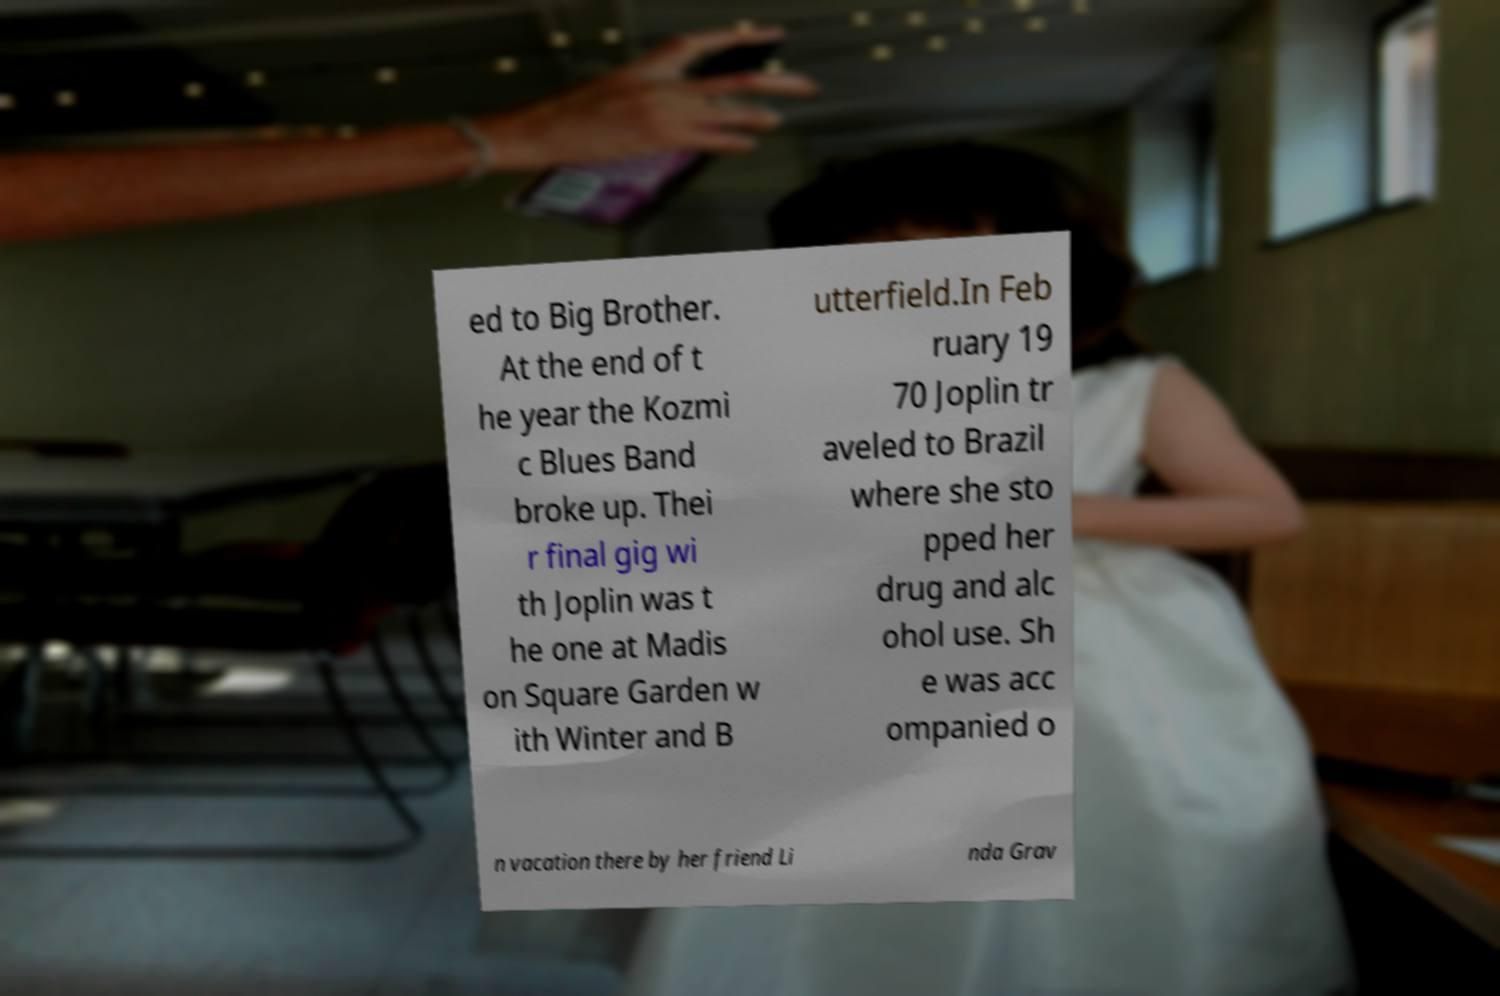Can you accurately transcribe the text from the provided image for me? ed to Big Brother. At the end of t he year the Kozmi c Blues Band broke up. Thei r final gig wi th Joplin was t he one at Madis on Square Garden w ith Winter and B utterfield.In Feb ruary 19 70 Joplin tr aveled to Brazil where she sto pped her drug and alc ohol use. Sh e was acc ompanied o n vacation there by her friend Li nda Grav 